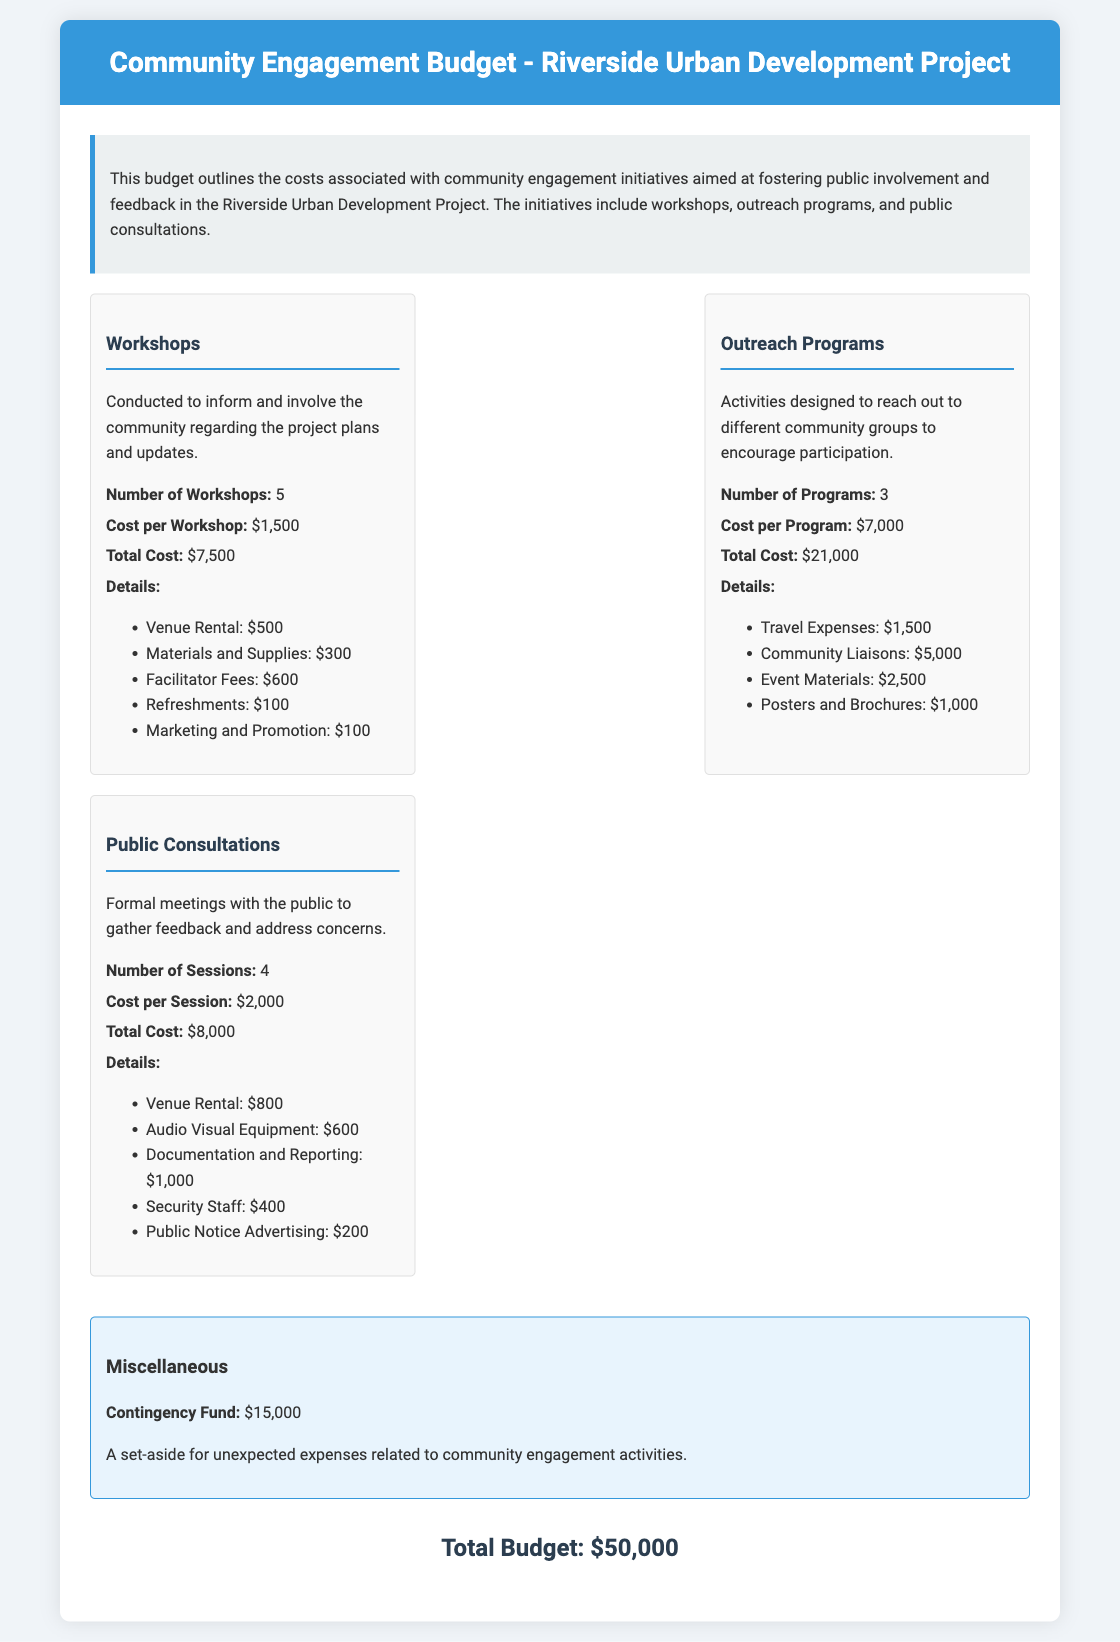What is the total cost for workshops? The total cost for workshops is mentioned in the budget breakdown for workshops. It states the total cost as $7,500.
Answer: $7,500 How many outreach programs are planned? The document specifies the number of outreach programs in the budget breakdown under outreach programs, showing 3 programs are planned.
Answer: 3 What is the contingency fund amount? The contingency fund amount is noted in the miscellaneous section of the document, specified as $15,000.
Answer: $15,000 What is the cost per public consultation session? The cost per public consultation session is detailed in the public consultations budget section, which indicates $2,000.
Answer: $2,000 How many workshops will be conducted? The number of workshops is provided in the workshops budget item, which states that 5 workshops will be conducted.
Answer: 5 What are the travel expenses for outreach programs? The travel expenses for outreach programs are listed in the outreach programs budget details as $1,500.
Answer: $1,500 What is the total budget for the community engagement initiatives? The total budget for the community engagement initiatives is mentioned at the end of the document as $50,000.
Answer: $50,000 What is included in the materials and supplies for workshops? The budget details under workshops specify materials and supplies costing $300.
Answer: $300 What is the total cost for public consultations? The total cost for public consultations can be found in the public consultations section, which totals $8,000.
Answer: $8,000 